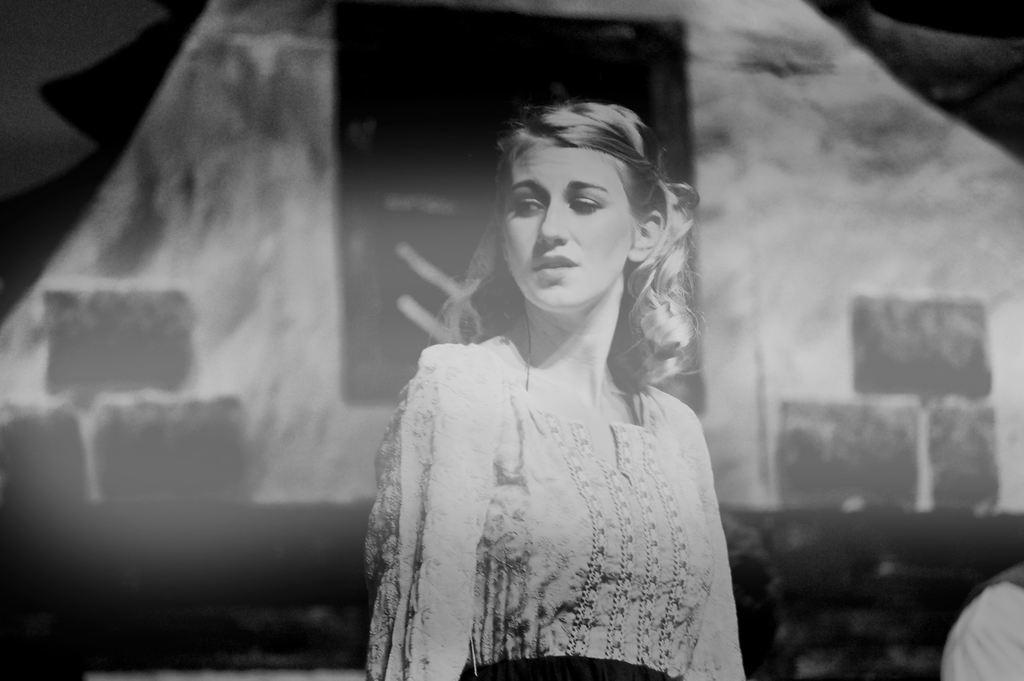Who is the main subject in the image? There is a woman in the image. What is the woman wearing? The woman is wearing a dress. Can you describe the background of the image? The background of the image is blurred. What type of ball can be heard in the background of the image? There is no ball or sound present in the image, as it only features a woman wearing a dress with a blurred background. 